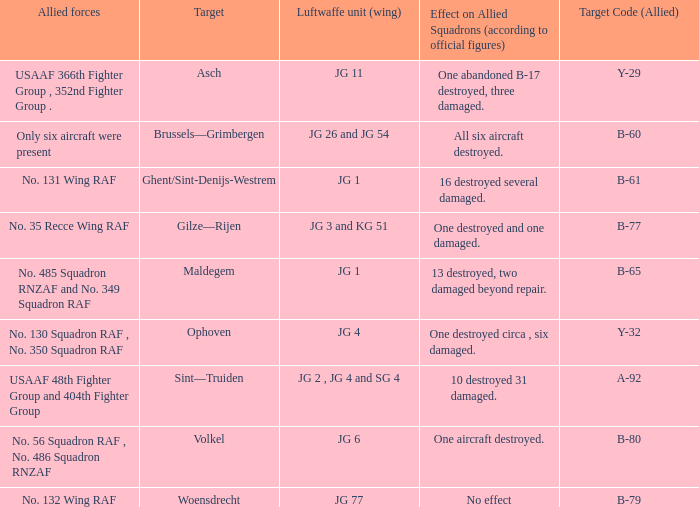What is the allied target code of the group that targetted ghent/sint-denijs-westrem? B-61. 